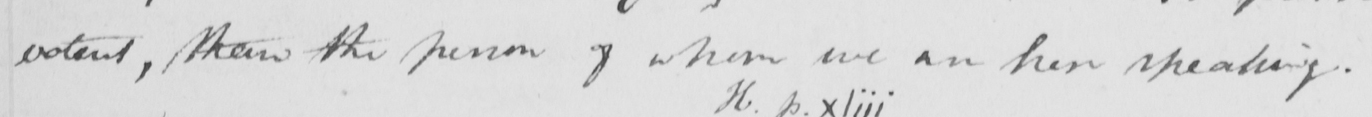What text is written in this handwritten line? <gap/>  , than the person of whom we are here speaking . 